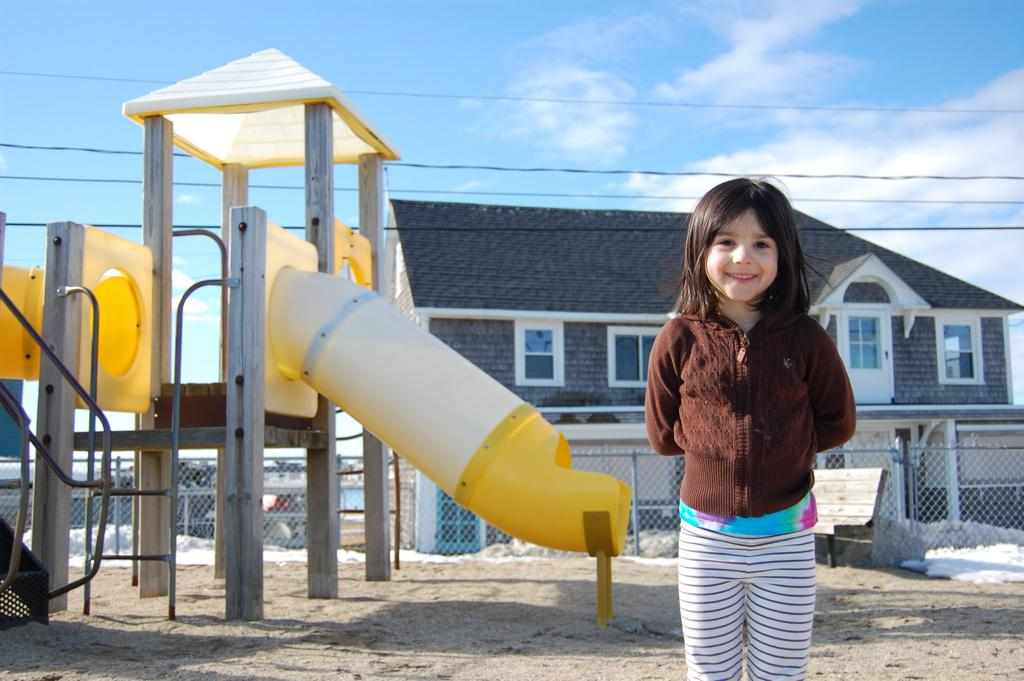What is the girl doing in the image? The girl is standing on the ground in the image. What can be seen on the left side of the image? There is a playground slide on the left side of the image. What is visible in the background of the image? There is fencing, a house, wires, and the sky visible in the background of the image. What type of stove is the lawyer using in the image? There is no stove or lawyer present in the image. How many cushions are on the slide in the image? There are no cushions on the slide in the image; it is a playground slide. 